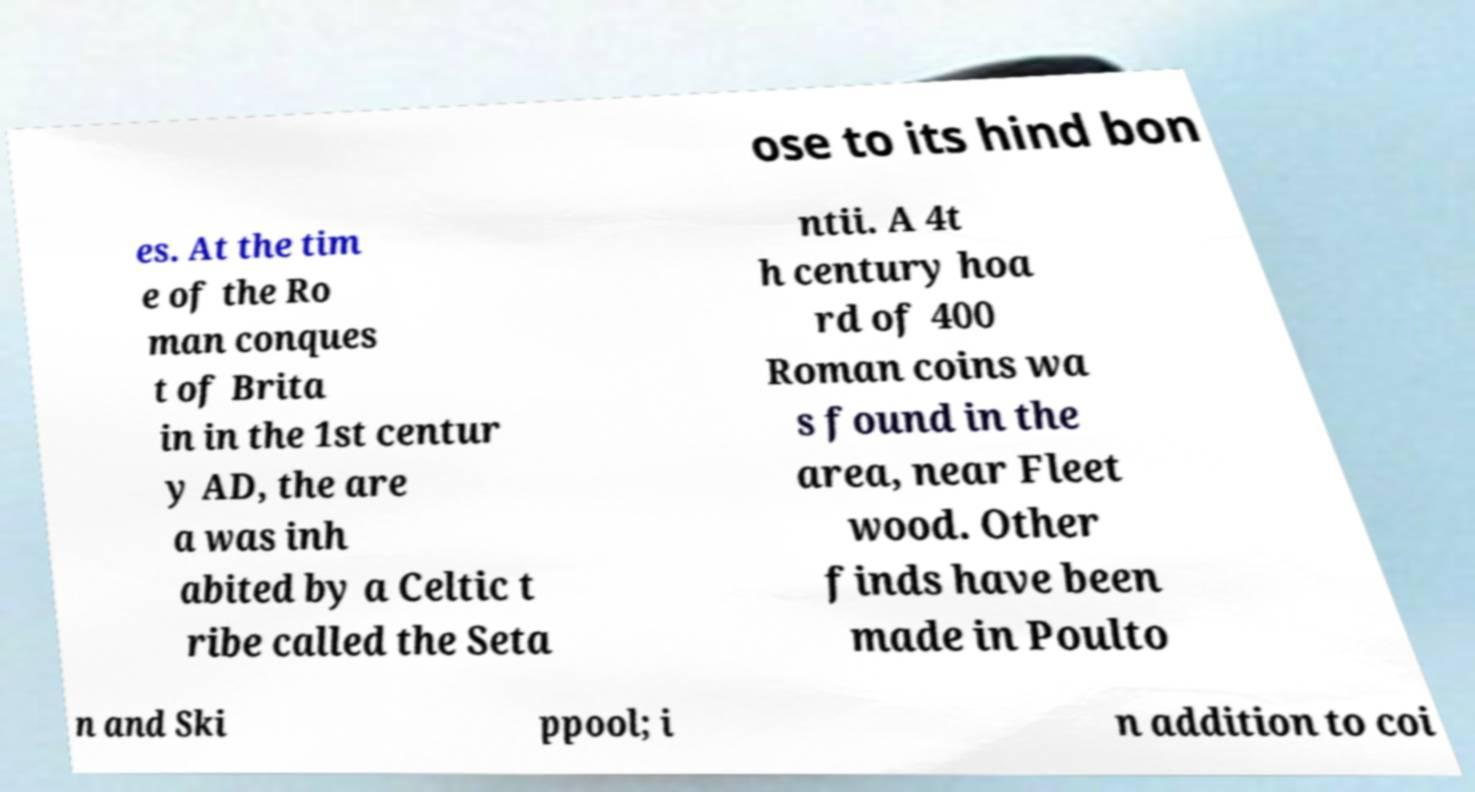Please read and relay the text visible in this image. What does it say? ose to its hind bon es. At the tim e of the Ro man conques t of Brita in in the 1st centur y AD, the are a was inh abited by a Celtic t ribe called the Seta ntii. A 4t h century hoa rd of 400 Roman coins wa s found in the area, near Fleet wood. Other finds have been made in Poulto n and Ski ppool; i n addition to coi 